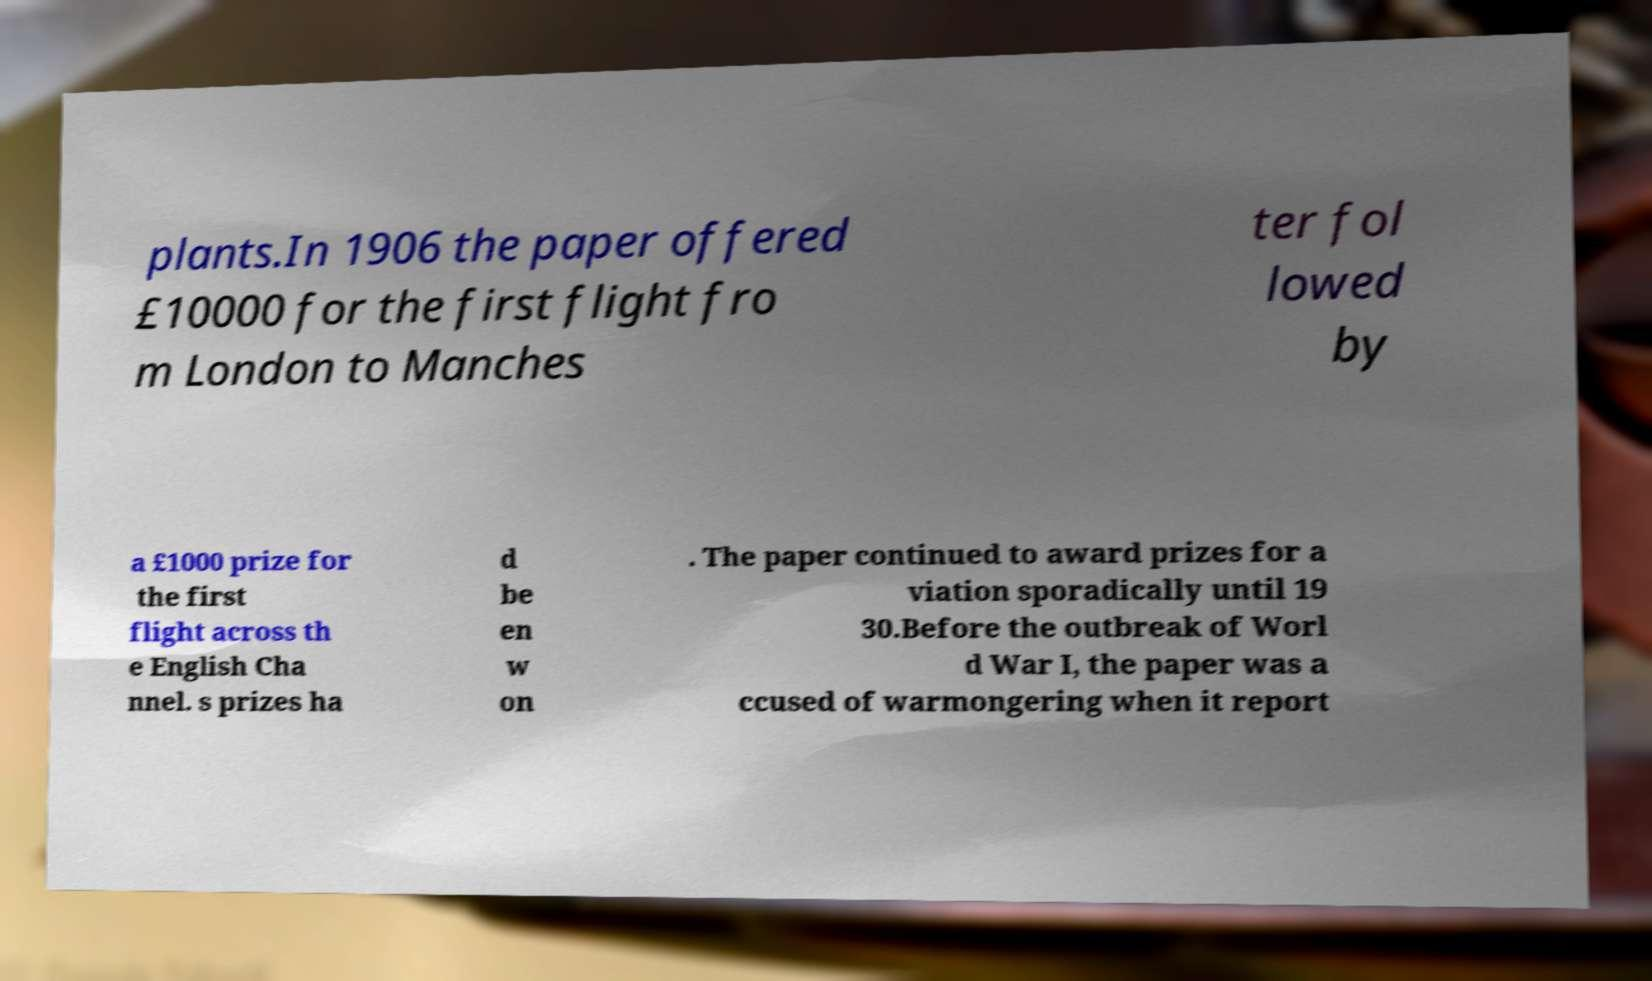For documentation purposes, I need the text within this image transcribed. Could you provide that? plants.In 1906 the paper offered £10000 for the first flight fro m London to Manches ter fol lowed by a £1000 prize for the first flight across th e English Cha nnel. s prizes ha d be en w on . The paper continued to award prizes for a viation sporadically until 19 30.Before the outbreak of Worl d War I, the paper was a ccused of warmongering when it report 